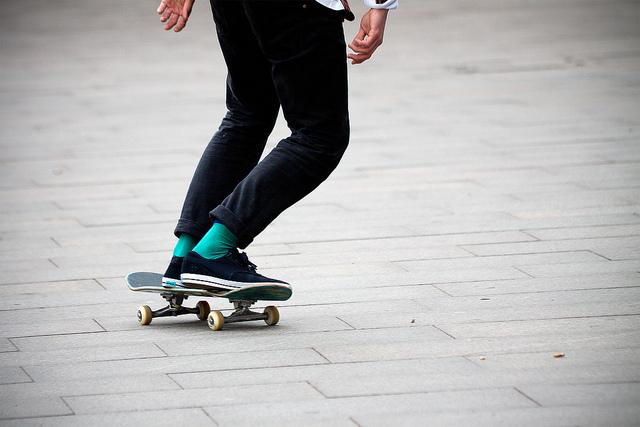What color socks is this person wearing?
Keep it brief. Green. Is the person riding on pavement?
Be succinct. Yes. What color are the wheels?
Quick response, please. White. How many wheels are shown?
Concise answer only. 4. 